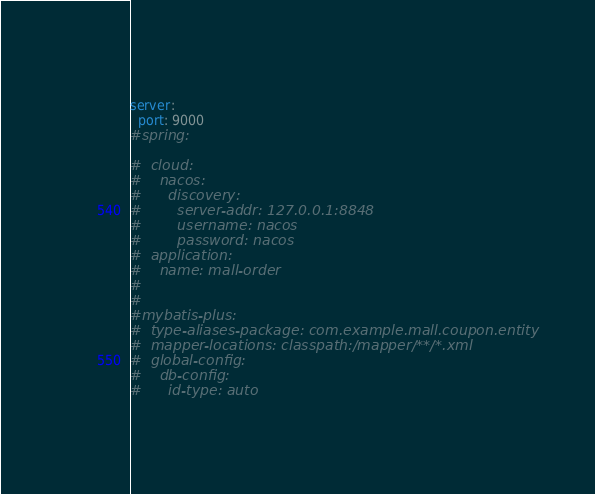Convert code to text. <code><loc_0><loc_0><loc_500><loc_500><_YAML_>server:
  port: 9000
#spring:

#  cloud:
#    nacos:
#      discovery:
#        server-addr: 127.0.0.1:8848
#        username: nacos
#        password: nacos
#  application:
#    name: mall-order
#
#
#mybatis-plus:
#  type-aliases-package: com.example.mall.coupon.entity
#  mapper-locations: classpath:/mapper/**/*.xml
#  global-config:
#    db-config:
#      id-type: auto</code> 